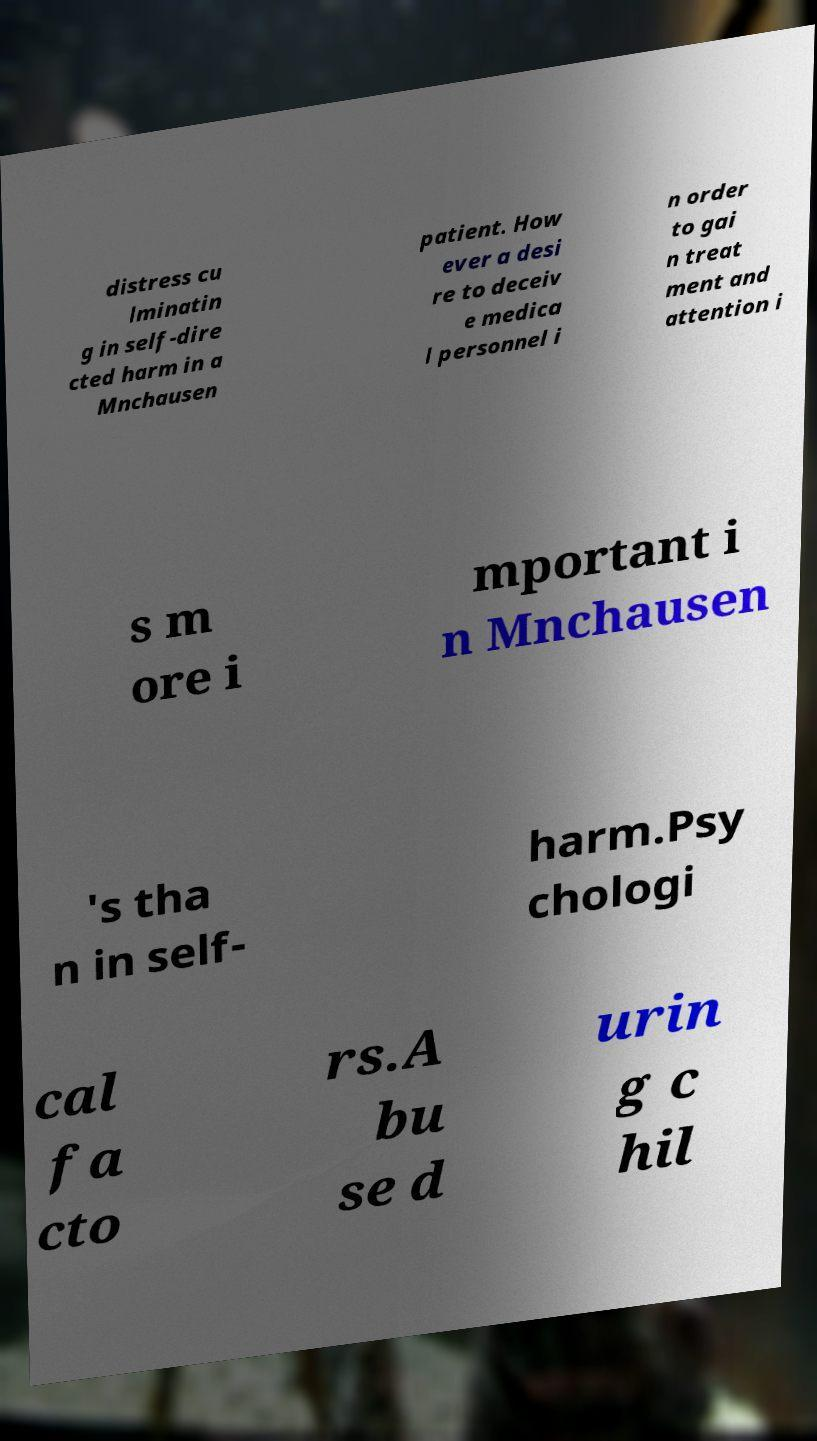Please identify and transcribe the text found in this image. distress cu lminatin g in self-dire cted harm in a Mnchausen patient. How ever a desi re to deceiv e medica l personnel i n order to gai n treat ment and attention i s m ore i mportant i n Mnchausen 's tha n in self- harm.Psy chologi cal fa cto rs.A bu se d urin g c hil 